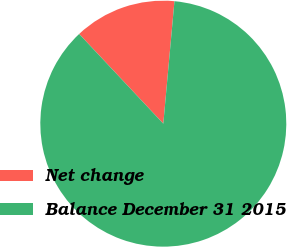Convert chart. <chart><loc_0><loc_0><loc_500><loc_500><pie_chart><fcel>Net change<fcel>Balance December 31 2015<nl><fcel>13.44%<fcel>86.56%<nl></chart> 